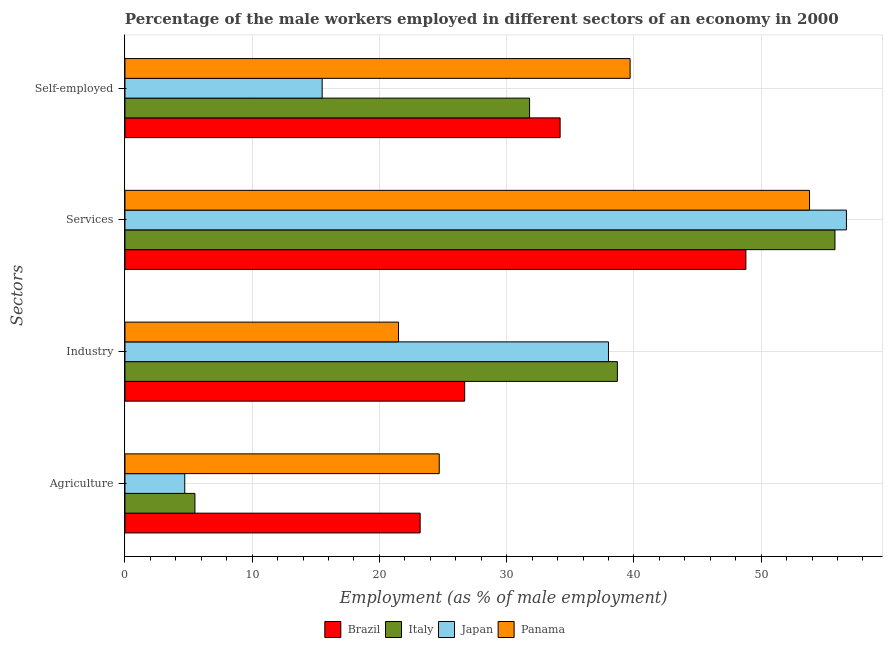How many different coloured bars are there?
Offer a terse response. 4. Are the number of bars per tick equal to the number of legend labels?
Offer a very short reply. Yes. Are the number of bars on each tick of the Y-axis equal?
Make the answer very short. Yes. How many bars are there on the 3rd tick from the bottom?
Make the answer very short. 4. What is the label of the 3rd group of bars from the top?
Your answer should be very brief. Industry. What is the percentage of self employed male workers in Italy?
Offer a very short reply. 31.8. Across all countries, what is the maximum percentage of male workers in agriculture?
Offer a very short reply. 24.7. Across all countries, what is the minimum percentage of male workers in services?
Give a very brief answer. 48.8. In which country was the percentage of male workers in agriculture maximum?
Offer a very short reply. Panama. In which country was the percentage of self employed male workers minimum?
Your answer should be compact. Japan. What is the total percentage of male workers in services in the graph?
Make the answer very short. 215.1. What is the difference between the percentage of self employed male workers in Italy and that in Panama?
Keep it short and to the point. -7.9. What is the difference between the percentage of male workers in agriculture in Italy and the percentage of male workers in services in Brazil?
Your response must be concise. -43.3. What is the average percentage of male workers in services per country?
Provide a succinct answer. 53.77. What is the difference between the percentage of male workers in agriculture and percentage of male workers in services in Italy?
Offer a terse response. -50.3. What is the ratio of the percentage of male workers in agriculture in Brazil to that in Panama?
Your answer should be very brief. 0.94. What is the difference between the highest and the second highest percentage of male workers in services?
Provide a succinct answer. 0.9. What is the difference between the highest and the lowest percentage of self employed male workers?
Your answer should be very brief. 24.2. In how many countries, is the percentage of male workers in industry greater than the average percentage of male workers in industry taken over all countries?
Keep it short and to the point. 2. Is the sum of the percentage of male workers in agriculture in Japan and Italy greater than the maximum percentage of male workers in industry across all countries?
Give a very brief answer. No. Is it the case that in every country, the sum of the percentage of male workers in agriculture and percentage of self employed male workers is greater than the sum of percentage of male workers in services and percentage of male workers in industry?
Your response must be concise. No. What does the 4th bar from the bottom in Services represents?
Offer a very short reply. Panama. Is it the case that in every country, the sum of the percentage of male workers in agriculture and percentage of male workers in industry is greater than the percentage of male workers in services?
Give a very brief answer. No. Are all the bars in the graph horizontal?
Give a very brief answer. Yes. What is the difference between two consecutive major ticks on the X-axis?
Ensure brevity in your answer.  10. Does the graph contain any zero values?
Offer a terse response. No. How many legend labels are there?
Provide a short and direct response. 4. What is the title of the graph?
Provide a succinct answer. Percentage of the male workers employed in different sectors of an economy in 2000. Does "Lebanon" appear as one of the legend labels in the graph?
Offer a terse response. No. What is the label or title of the X-axis?
Offer a very short reply. Employment (as % of male employment). What is the label or title of the Y-axis?
Offer a very short reply. Sectors. What is the Employment (as % of male employment) in Brazil in Agriculture?
Give a very brief answer. 23.2. What is the Employment (as % of male employment) in Italy in Agriculture?
Offer a terse response. 5.5. What is the Employment (as % of male employment) of Japan in Agriculture?
Your answer should be compact. 4.7. What is the Employment (as % of male employment) of Panama in Agriculture?
Offer a terse response. 24.7. What is the Employment (as % of male employment) in Brazil in Industry?
Ensure brevity in your answer.  26.7. What is the Employment (as % of male employment) of Italy in Industry?
Your answer should be compact. 38.7. What is the Employment (as % of male employment) of Panama in Industry?
Give a very brief answer. 21.5. What is the Employment (as % of male employment) in Brazil in Services?
Offer a terse response. 48.8. What is the Employment (as % of male employment) in Italy in Services?
Your answer should be compact. 55.8. What is the Employment (as % of male employment) of Japan in Services?
Make the answer very short. 56.7. What is the Employment (as % of male employment) in Panama in Services?
Offer a very short reply. 53.8. What is the Employment (as % of male employment) of Brazil in Self-employed?
Give a very brief answer. 34.2. What is the Employment (as % of male employment) of Italy in Self-employed?
Offer a terse response. 31.8. What is the Employment (as % of male employment) in Japan in Self-employed?
Give a very brief answer. 15.5. What is the Employment (as % of male employment) of Panama in Self-employed?
Provide a succinct answer. 39.7. Across all Sectors, what is the maximum Employment (as % of male employment) in Brazil?
Your answer should be very brief. 48.8. Across all Sectors, what is the maximum Employment (as % of male employment) in Italy?
Offer a terse response. 55.8. Across all Sectors, what is the maximum Employment (as % of male employment) of Japan?
Make the answer very short. 56.7. Across all Sectors, what is the maximum Employment (as % of male employment) of Panama?
Keep it short and to the point. 53.8. Across all Sectors, what is the minimum Employment (as % of male employment) in Brazil?
Your response must be concise. 23.2. Across all Sectors, what is the minimum Employment (as % of male employment) of Japan?
Your response must be concise. 4.7. Across all Sectors, what is the minimum Employment (as % of male employment) in Panama?
Your response must be concise. 21.5. What is the total Employment (as % of male employment) of Brazil in the graph?
Ensure brevity in your answer.  132.9. What is the total Employment (as % of male employment) of Italy in the graph?
Provide a succinct answer. 131.8. What is the total Employment (as % of male employment) in Japan in the graph?
Make the answer very short. 114.9. What is the total Employment (as % of male employment) of Panama in the graph?
Your response must be concise. 139.7. What is the difference between the Employment (as % of male employment) of Brazil in Agriculture and that in Industry?
Provide a short and direct response. -3.5. What is the difference between the Employment (as % of male employment) of Italy in Agriculture and that in Industry?
Keep it short and to the point. -33.2. What is the difference between the Employment (as % of male employment) of Japan in Agriculture and that in Industry?
Make the answer very short. -33.3. What is the difference between the Employment (as % of male employment) of Brazil in Agriculture and that in Services?
Provide a short and direct response. -25.6. What is the difference between the Employment (as % of male employment) in Italy in Agriculture and that in Services?
Make the answer very short. -50.3. What is the difference between the Employment (as % of male employment) in Japan in Agriculture and that in Services?
Make the answer very short. -52. What is the difference between the Employment (as % of male employment) of Panama in Agriculture and that in Services?
Offer a very short reply. -29.1. What is the difference between the Employment (as % of male employment) of Italy in Agriculture and that in Self-employed?
Make the answer very short. -26.3. What is the difference between the Employment (as % of male employment) of Panama in Agriculture and that in Self-employed?
Provide a succinct answer. -15. What is the difference between the Employment (as % of male employment) of Brazil in Industry and that in Services?
Your answer should be very brief. -22.1. What is the difference between the Employment (as % of male employment) in Italy in Industry and that in Services?
Provide a succinct answer. -17.1. What is the difference between the Employment (as % of male employment) in Japan in Industry and that in Services?
Your response must be concise. -18.7. What is the difference between the Employment (as % of male employment) in Panama in Industry and that in Services?
Ensure brevity in your answer.  -32.3. What is the difference between the Employment (as % of male employment) of Brazil in Industry and that in Self-employed?
Offer a terse response. -7.5. What is the difference between the Employment (as % of male employment) in Italy in Industry and that in Self-employed?
Provide a short and direct response. 6.9. What is the difference between the Employment (as % of male employment) of Japan in Industry and that in Self-employed?
Provide a short and direct response. 22.5. What is the difference between the Employment (as % of male employment) of Panama in Industry and that in Self-employed?
Provide a short and direct response. -18.2. What is the difference between the Employment (as % of male employment) in Japan in Services and that in Self-employed?
Offer a very short reply. 41.2. What is the difference between the Employment (as % of male employment) in Panama in Services and that in Self-employed?
Your answer should be very brief. 14.1. What is the difference between the Employment (as % of male employment) in Brazil in Agriculture and the Employment (as % of male employment) in Italy in Industry?
Your answer should be very brief. -15.5. What is the difference between the Employment (as % of male employment) in Brazil in Agriculture and the Employment (as % of male employment) in Japan in Industry?
Offer a very short reply. -14.8. What is the difference between the Employment (as % of male employment) in Italy in Agriculture and the Employment (as % of male employment) in Japan in Industry?
Provide a short and direct response. -32.5. What is the difference between the Employment (as % of male employment) in Italy in Agriculture and the Employment (as % of male employment) in Panama in Industry?
Ensure brevity in your answer.  -16. What is the difference between the Employment (as % of male employment) of Japan in Agriculture and the Employment (as % of male employment) of Panama in Industry?
Offer a terse response. -16.8. What is the difference between the Employment (as % of male employment) in Brazil in Agriculture and the Employment (as % of male employment) in Italy in Services?
Give a very brief answer. -32.6. What is the difference between the Employment (as % of male employment) of Brazil in Agriculture and the Employment (as % of male employment) of Japan in Services?
Provide a succinct answer. -33.5. What is the difference between the Employment (as % of male employment) of Brazil in Agriculture and the Employment (as % of male employment) of Panama in Services?
Provide a short and direct response. -30.6. What is the difference between the Employment (as % of male employment) of Italy in Agriculture and the Employment (as % of male employment) of Japan in Services?
Your answer should be very brief. -51.2. What is the difference between the Employment (as % of male employment) of Italy in Agriculture and the Employment (as % of male employment) of Panama in Services?
Your answer should be compact. -48.3. What is the difference between the Employment (as % of male employment) of Japan in Agriculture and the Employment (as % of male employment) of Panama in Services?
Ensure brevity in your answer.  -49.1. What is the difference between the Employment (as % of male employment) in Brazil in Agriculture and the Employment (as % of male employment) in Italy in Self-employed?
Offer a terse response. -8.6. What is the difference between the Employment (as % of male employment) in Brazil in Agriculture and the Employment (as % of male employment) in Panama in Self-employed?
Provide a short and direct response. -16.5. What is the difference between the Employment (as % of male employment) of Italy in Agriculture and the Employment (as % of male employment) of Panama in Self-employed?
Your answer should be compact. -34.2. What is the difference between the Employment (as % of male employment) in Japan in Agriculture and the Employment (as % of male employment) in Panama in Self-employed?
Your response must be concise. -35. What is the difference between the Employment (as % of male employment) in Brazil in Industry and the Employment (as % of male employment) in Italy in Services?
Provide a short and direct response. -29.1. What is the difference between the Employment (as % of male employment) of Brazil in Industry and the Employment (as % of male employment) of Japan in Services?
Give a very brief answer. -30. What is the difference between the Employment (as % of male employment) in Brazil in Industry and the Employment (as % of male employment) in Panama in Services?
Provide a short and direct response. -27.1. What is the difference between the Employment (as % of male employment) of Italy in Industry and the Employment (as % of male employment) of Japan in Services?
Keep it short and to the point. -18. What is the difference between the Employment (as % of male employment) in Italy in Industry and the Employment (as % of male employment) in Panama in Services?
Provide a short and direct response. -15.1. What is the difference between the Employment (as % of male employment) in Japan in Industry and the Employment (as % of male employment) in Panama in Services?
Your response must be concise. -15.8. What is the difference between the Employment (as % of male employment) in Brazil in Industry and the Employment (as % of male employment) in Italy in Self-employed?
Offer a terse response. -5.1. What is the difference between the Employment (as % of male employment) of Brazil in Industry and the Employment (as % of male employment) of Panama in Self-employed?
Make the answer very short. -13. What is the difference between the Employment (as % of male employment) of Italy in Industry and the Employment (as % of male employment) of Japan in Self-employed?
Offer a terse response. 23.2. What is the difference between the Employment (as % of male employment) in Brazil in Services and the Employment (as % of male employment) in Japan in Self-employed?
Give a very brief answer. 33.3. What is the difference between the Employment (as % of male employment) of Brazil in Services and the Employment (as % of male employment) of Panama in Self-employed?
Offer a very short reply. 9.1. What is the difference between the Employment (as % of male employment) of Italy in Services and the Employment (as % of male employment) of Japan in Self-employed?
Offer a terse response. 40.3. What is the difference between the Employment (as % of male employment) of Japan in Services and the Employment (as % of male employment) of Panama in Self-employed?
Your answer should be very brief. 17. What is the average Employment (as % of male employment) of Brazil per Sectors?
Give a very brief answer. 33.23. What is the average Employment (as % of male employment) of Italy per Sectors?
Make the answer very short. 32.95. What is the average Employment (as % of male employment) in Japan per Sectors?
Your answer should be very brief. 28.73. What is the average Employment (as % of male employment) in Panama per Sectors?
Make the answer very short. 34.92. What is the difference between the Employment (as % of male employment) in Brazil and Employment (as % of male employment) in Italy in Agriculture?
Provide a short and direct response. 17.7. What is the difference between the Employment (as % of male employment) of Italy and Employment (as % of male employment) of Japan in Agriculture?
Offer a very short reply. 0.8. What is the difference between the Employment (as % of male employment) of Italy and Employment (as % of male employment) of Panama in Agriculture?
Ensure brevity in your answer.  -19.2. What is the difference between the Employment (as % of male employment) in Japan and Employment (as % of male employment) in Panama in Agriculture?
Give a very brief answer. -20. What is the difference between the Employment (as % of male employment) of Brazil and Employment (as % of male employment) of Italy in Industry?
Your answer should be very brief. -12. What is the difference between the Employment (as % of male employment) of Italy and Employment (as % of male employment) of Japan in Industry?
Make the answer very short. 0.7. What is the difference between the Employment (as % of male employment) in Japan and Employment (as % of male employment) in Panama in Industry?
Your answer should be very brief. 16.5. What is the difference between the Employment (as % of male employment) of Brazil and Employment (as % of male employment) of Japan in Services?
Provide a succinct answer. -7.9. What is the difference between the Employment (as % of male employment) of Italy and Employment (as % of male employment) of Japan in Services?
Provide a succinct answer. -0.9. What is the difference between the Employment (as % of male employment) of Brazil and Employment (as % of male employment) of Italy in Self-employed?
Make the answer very short. 2.4. What is the difference between the Employment (as % of male employment) of Brazil and Employment (as % of male employment) of Panama in Self-employed?
Offer a very short reply. -5.5. What is the difference between the Employment (as % of male employment) of Japan and Employment (as % of male employment) of Panama in Self-employed?
Your response must be concise. -24.2. What is the ratio of the Employment (as % of male employment) of Brazil in Agriculture to that in Industry?
Provide a short and direct response. 0.87. What is the ratio of the Employment (as % of male employment) of Italy in Agriculture to that in Industry?
Offer a terse response. 0.14. What is the ratio of the Employment (as % of male employment) in Japan in Agriculture to that in Industry?
Provide a short and direct response. 0.12. What is the ratio of the Employment (as % of male employment) in Panama in Agriculture to that in Industry?
Make the answer very short. 1.15. What is the ratio of the Employment (as % of male employment) in Brazil in Agriculture to that in Services?
Keep it short and to the point. 0.48. What is the ratio of the Employment (as % of male employment) of Italy in Agriculture to that in Services?
Keep it short and to the point. 0.1. What is the ratio of the Employment (as % of male employment) of Japan in Agriculture to that in Services?
Ensure brevity in your answer.  0.08. What is the ratio of the Employment (as % of male employment) of Panama in Agriculture to that in Services?
Ensure brevity in your answer.  0.46. What is the ratio of the Employment (as % of male employment) of Brazil in Agriculture to that in Self-employed?
Offer a very short reply. 0.68. What is the ratio of the Employment (as % of male employment) of Italy in Agriculture to that in Self-employed?
Keep it short and to the point. 0.17. What is the ratio of the Employment (as % of male employment) in Japan in Agriculture to that in Self-employed?
Provide a short and direct response. 0.3. What is the ratio of the Employment (as % of male employment) in Panama in Agriculture to that in Self-employed?
Your answer should be very brief. 0.62. What is the ratio of the Employment (as % of male employment) of Brazil in Industry to that in Services?
Your response must be concise. 0.55. What is the ratio of the Employment (as % of male employment) in Italy in Industry to that in Services?
Your answer should be compact. 0.69. What is the ratio of the Employment (as % of male employment) of Japan in Industry to that in Services?
Offer a terse response. 0.67. What is the ratio of the Employment (as % of male employment) of Panama in Industry to that in Services?
Make the answer very short. 0.4. What is the ratio of the Employment (as % of male employment) in Brazil in Industry to that in Self-employed?
Make the answer very short. 0.78. What is the ratio of the Employment (as % of male employment) of Italy in Industry to that in Self-employed?
Provide a succinct answer. 1.22. What is the ratio of the Employment (as % of male employment) in Japan in Industry to that in Self-employed?
Make the answer very short. 2.45. What is the ratio of the Employment (as % of male employment) in Panama in Industry to that in Self-employed?
Your answer should be very brief. 0.54. What is the ratio of the Employment (as % of male employment) in Brazil in Services to that in Self-employed?
Give a very brief answer. 1.43. What is the ratio of the Employment (as % of male employment) in Italy in Services to that in Self-employed?
Ensure brevity in your answer.  1.75. What is the ratio of the Employment (as % of male employment) of Japan in Services to that in Self-employed?
Give a very brief answer. 3.66. What is the ratio of the Employment (as % of male employment) of Panama in Services to that in Self-employed?
Your answer should be very brief. 1.36. What is the difference between the highest and the second highest Employment (as % of male employment) of Italy?
Your response must be concise. 17.1. What is the difference between the highest and the second highest Employment (as % of male employment) in Japan?
Offer a very short reply. 18.7. What is the difference between the highest and the lowest Employment (as % of male employment) of Brazil?
Give a very brief answer. 25.6. What is the difference between the highest and the lowest Employment (as % of male employment) in Italy?
Keep it short and to the point. 50.3. What is the difference between the highest and the lowest Employment (as % of male employment) of Japan?
Give a very brief answer. 52. What is the difference between the highest and the lowest Employment (as % of male employment) of Panama?
Offer a terse response. 32.3. 